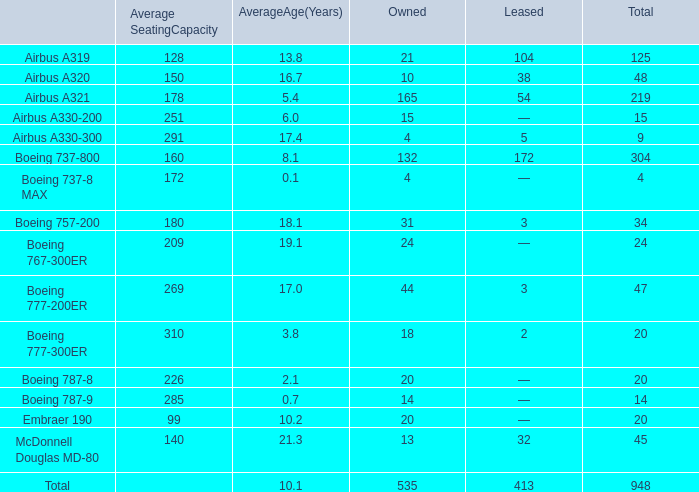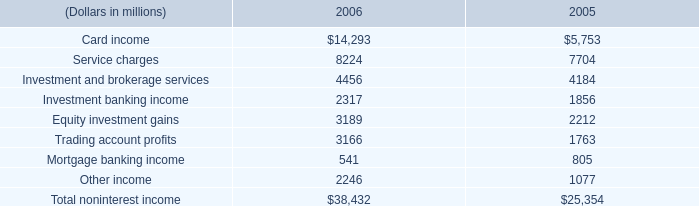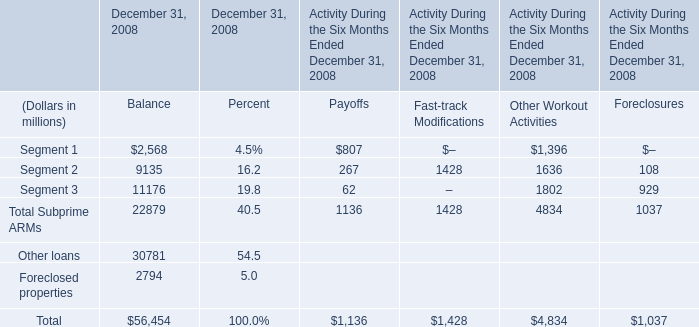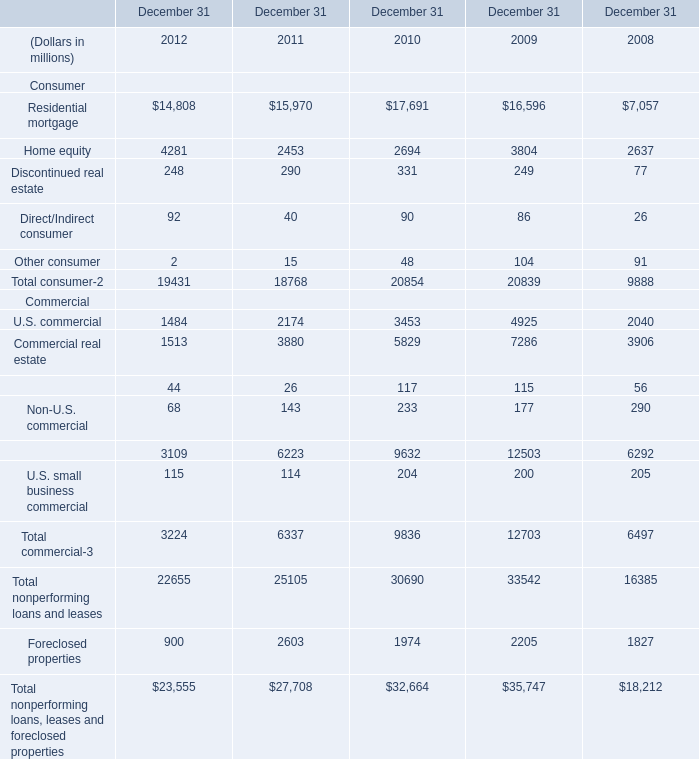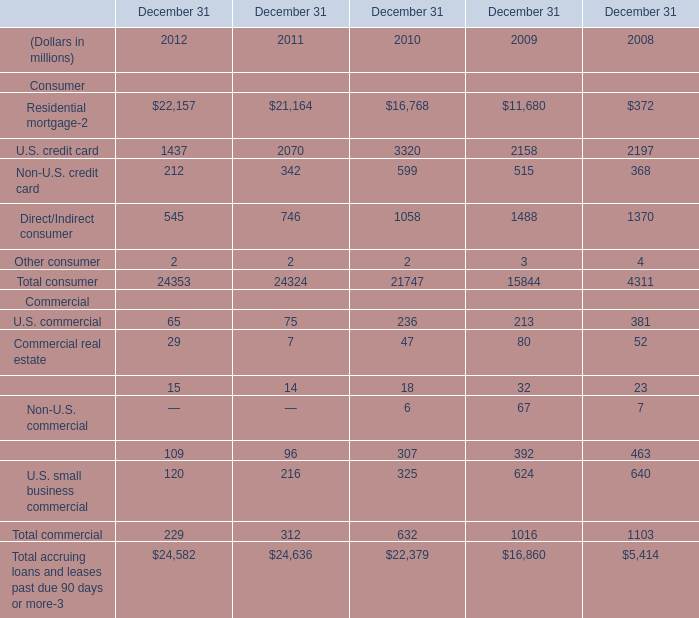What will Home equity be like in 2013 if it develops with the same increasing rate as current? (in millions) 
Computations: ((1 + ((4281 - 2453) / 2453)) * 4281)
Answer: 7471.24378. 